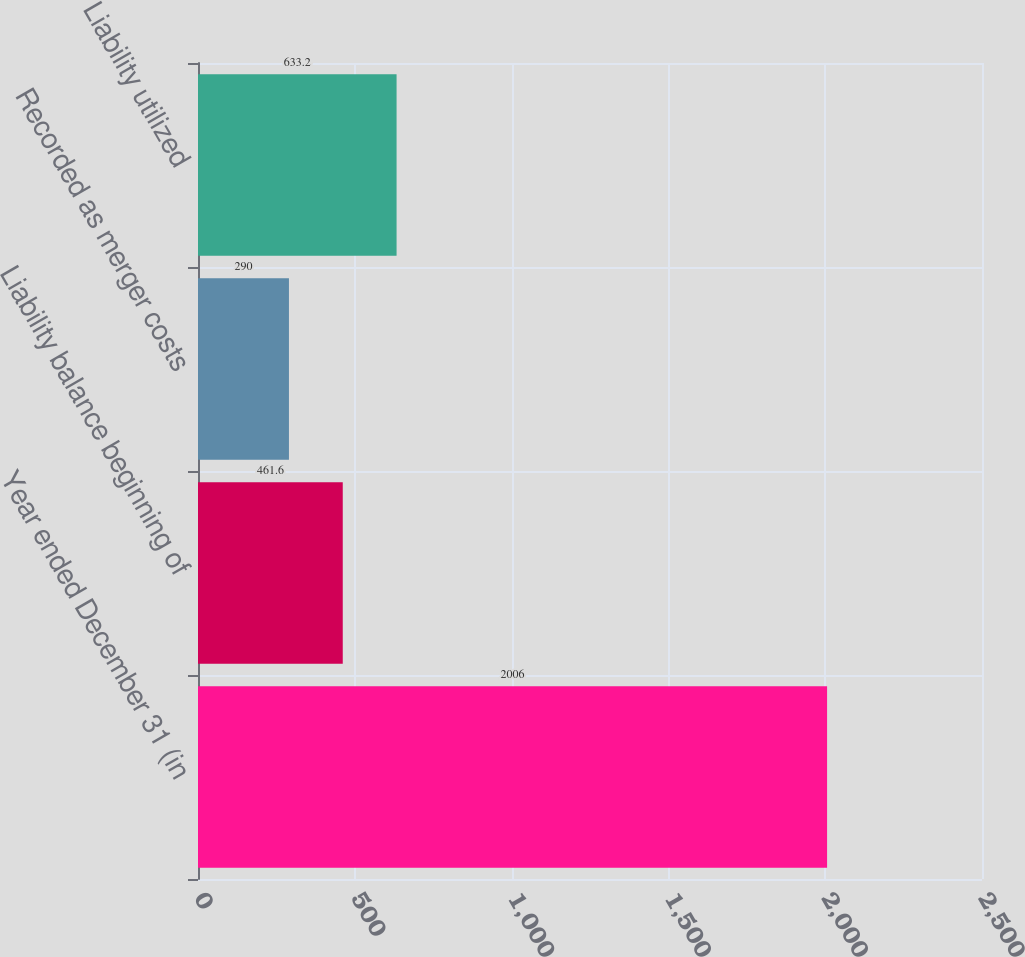Convert chart. <chart><loc_0><loc_0><loc_500><loc_500><bar_chart><fcel>Year ended December 31 (in<fcel>Liability balance beginning of<fcel>Recorded as merger costs<fcel>Liability utilized<nl><fcel>2006<fcel>461.6<fcel>290<fcel>633.2<nl></chart> 